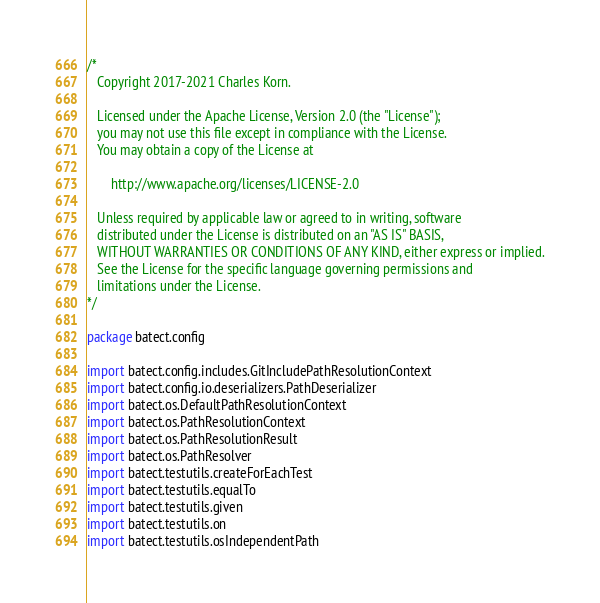<code> <loc_0><loc_0><loc_500><loc_500><_Kotlin_>/*
   Copyright 2017-2021 Charles Korn.

   Licensed under the Apache License, Version 2.0 (the "License");
   you may not use this file except in compliance with the License.
   You may obtain a copy of the License at

       http://www.apache.org/licenses/LICENSE-2.0

   Unless required by applicable law or agreed to in writing, software
   distributed under the License is distributed on an "AS IS" BASIS,
   WITHOUT WARRANTIES OR CONDITIONS OF ANY KIND, either express or implied.
   See the License for the specific language governing permissions and
   limitations under the License.
*/

package batect.config

import batect.config.includes.GitIncludePathResolutionContext
import batect.config.io.deserializers.PathDeserializer
import batect.os.DefaultPathResolutionContext
import batect.os.PathResolutionContext
import batect.os.PathResolutionResult
import batect.os.PathResolver
import batect.testutils.createForEachTest
import batect.testutils.equalTo
import batect.testutils.given
import batect.testutils.on
import batect.testutils.osIndependentPath</code> 